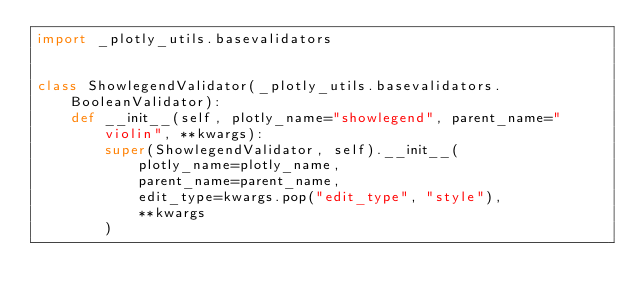<code> <loc_0><loc_0><loc_500><loc_500><_Python_>import _plotly_utils.basevalidators


class ShowlegendValidator(_plotly_utils.basevalidators.BooleanValidator):
    def __init__(self, plotly_name="showlegend", parent_name="violin", **kwargs):
        super(ShowlegendValidator, self).__init__(
            plotly_name=plotly_name,
            parent_name=parent_name,
            edit_type=kwargs.pop("edit_type", "style"),
            **kwargs
        )
</code> 